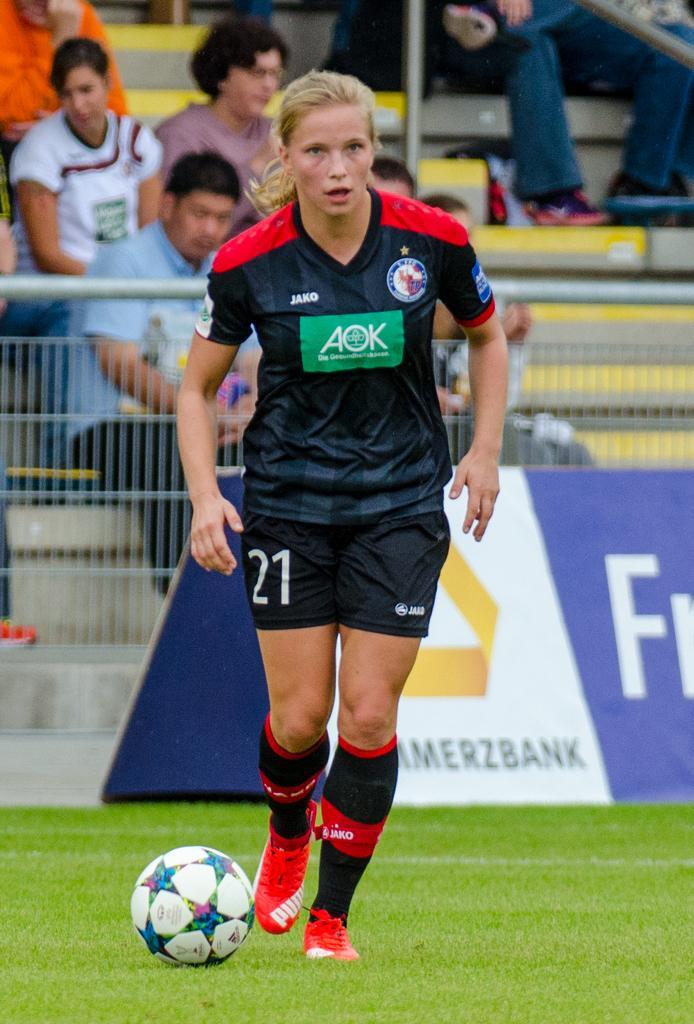In one or two sentences, can you explain what this image depicts? This image is clicked in a ground. There is a woman wearing black dress and playing football. At the bottom there is green grass. In the background, there are people sitting on the steps. 